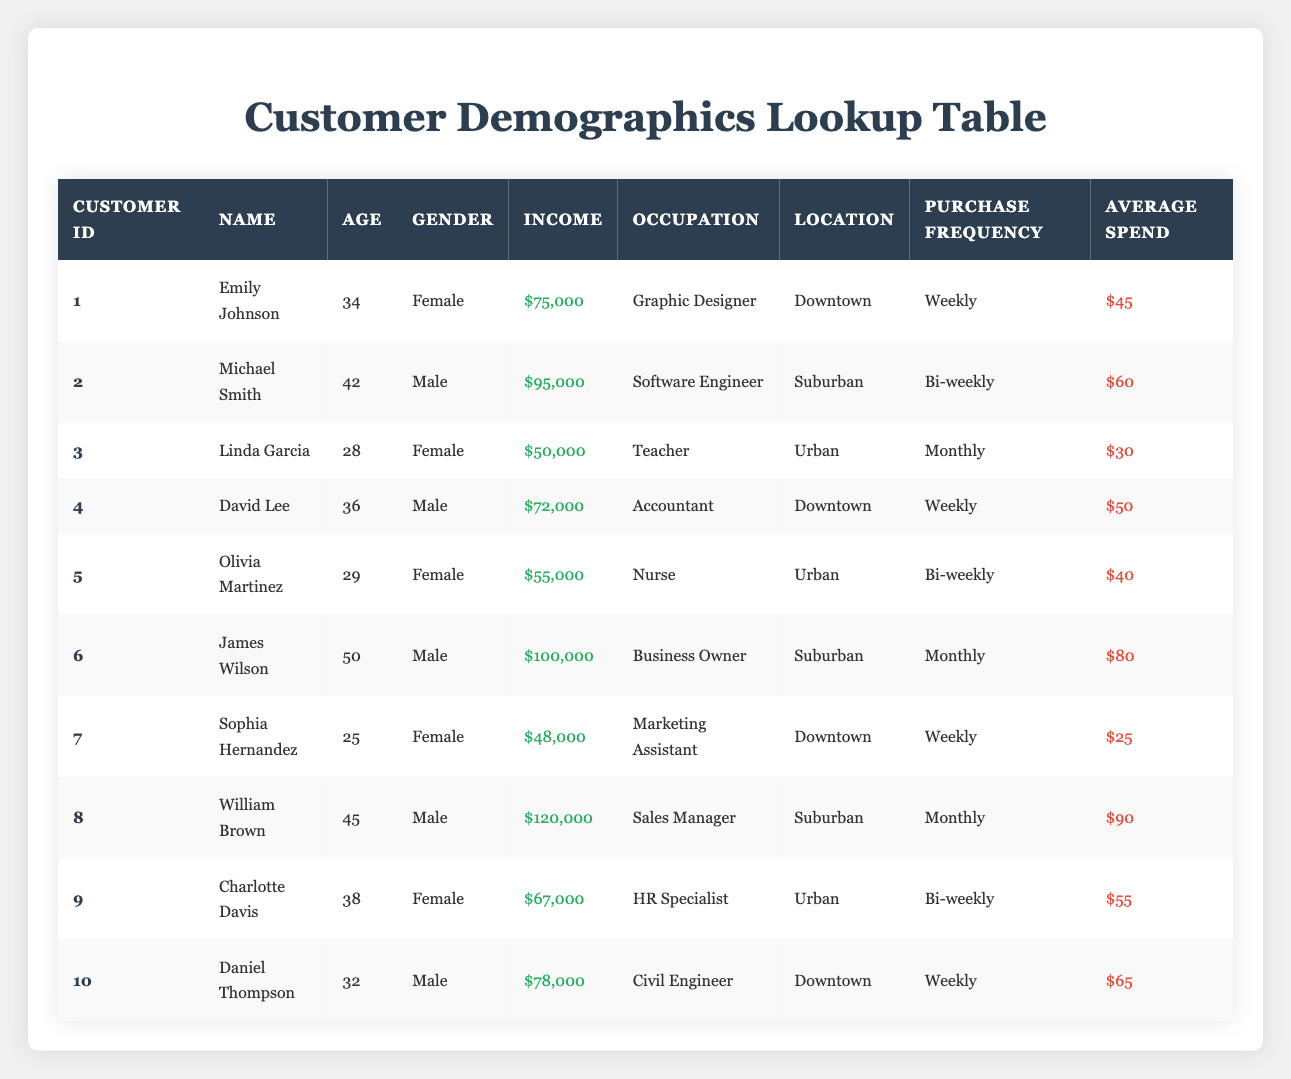What is the average income of all customers listed? To calculate the average income, add all customer incomes together: $75,000 + $95,000 + $50,000 + $72,000 + $55,000 + $100,000 + $48,000 + $120,000 + $67,000 + $78,000 = $790,000. Then divide by the number of customers (10): $790,000 / 10 = $79,000.
Answer: $79,000 How many customers are purchasing weekly? In the table, the customers with weekly purchase frequency are Emily Johnson, David Lee, Sophia Hernandez, and Daniel Thompson. Counting them gives us 4 customers.
Answer: 4 Is there a customer with a higher average spend than $85? Reviewing the average spends in the table, the highest is $90 by William Brown. This is indeed above $85.
Answer: Yes What is the total average spend of customers in the Urban location? The average spend for Urban customers is $30 (Linda Garcia) + $40 (Olivia Martinez) + $55 (Charlotte Davis) = $125. To find the average, divide by the number of Urban customers (3): $125 / 3 = $41.67.
Answer: $41.67 How does the income of female customers compare to male customers? The total income for female customers is $75,000 + $50,000 + $55,000 + $67,000 = $247,000. The total income for male customers is $95,000 + $72,000 + $100,000 + $120,000 + $78,000 = $465,000. Males have a total income significantly higher than females.
Answer: Males earn more What percentage of male customers are from the Downtown location? There are 5 male customers total. The male customers from Downtown are David Lee and Daniel Thompson, totaling 2. To find the percentage: (2 / 5) * 100 = 40%.
Answer: 40% Identify the oldest customer and their occupation. The oldest customer is James Wilson, who is 50 years old and works as a Business Owner.
Answer: James Wilson, Business Owner Which customer has the highest average spend? William Brown has the highest average spend of $90.
Answer: William Brown How many customers have an income less than $60,000? The customers with incomes below $60,000 are Linda Garcia ($50,000) and Sophia Hernandez ($48,000), totaling 2 customers in this category.
Answer: 2 